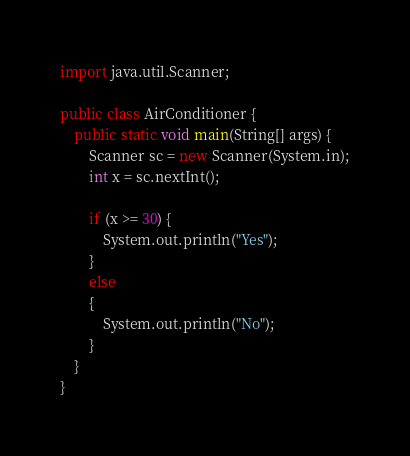<code> <loc_0><loc_0><loc_500><loc_500><_Java_>import java.util.Scanner;

public class AirConditioner {
    public static void main(String[] args) {
        Scanner sc = new Scanner(System.in);
        int x = sc.nextInt();

        if (x >= 30) {
            System.out.println("Yes");
        }
        else
        {
            System.out.println("No");
        }
    }
}
</code> 